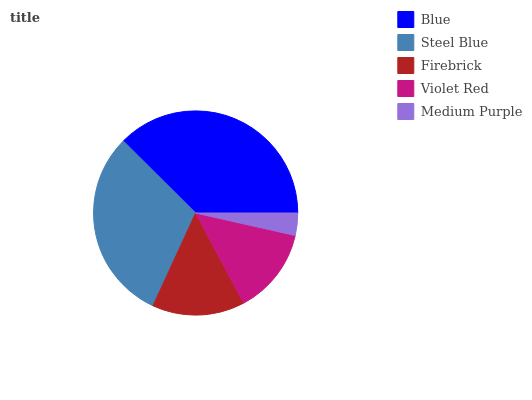Is Medium Purple the minimum?
Answer yes or no. Yes. Is Blue the maximum?
Answer yes or no. Yes. Is Steel Blue the minimum?
Answer yes or no. No. Is Steel Blue the maximum?
Answer yes or no. No. Is Blue greater than Steel Blue?
Answer yes or no. Yes. Is Steel Blue less than Blue?
Answer yes or no. Yes. Is Steel Blue greater than Blue?
Answer yes or no. No. Is Blue less than Steel Blue?
Answer yes or no. No. Is Firebrick the high median?
Answer yes or no. Yes. Is Firebrick the low median?
Answer yes or no. Yes. Is Blue the high median?
Answer yes or no. No. Is Blue the low median?
Answer yes or no. No. 